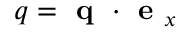<formula> <loc_0><loc_0><loc_500><loc_500>q = q \cdot e _ { x }</formula> 